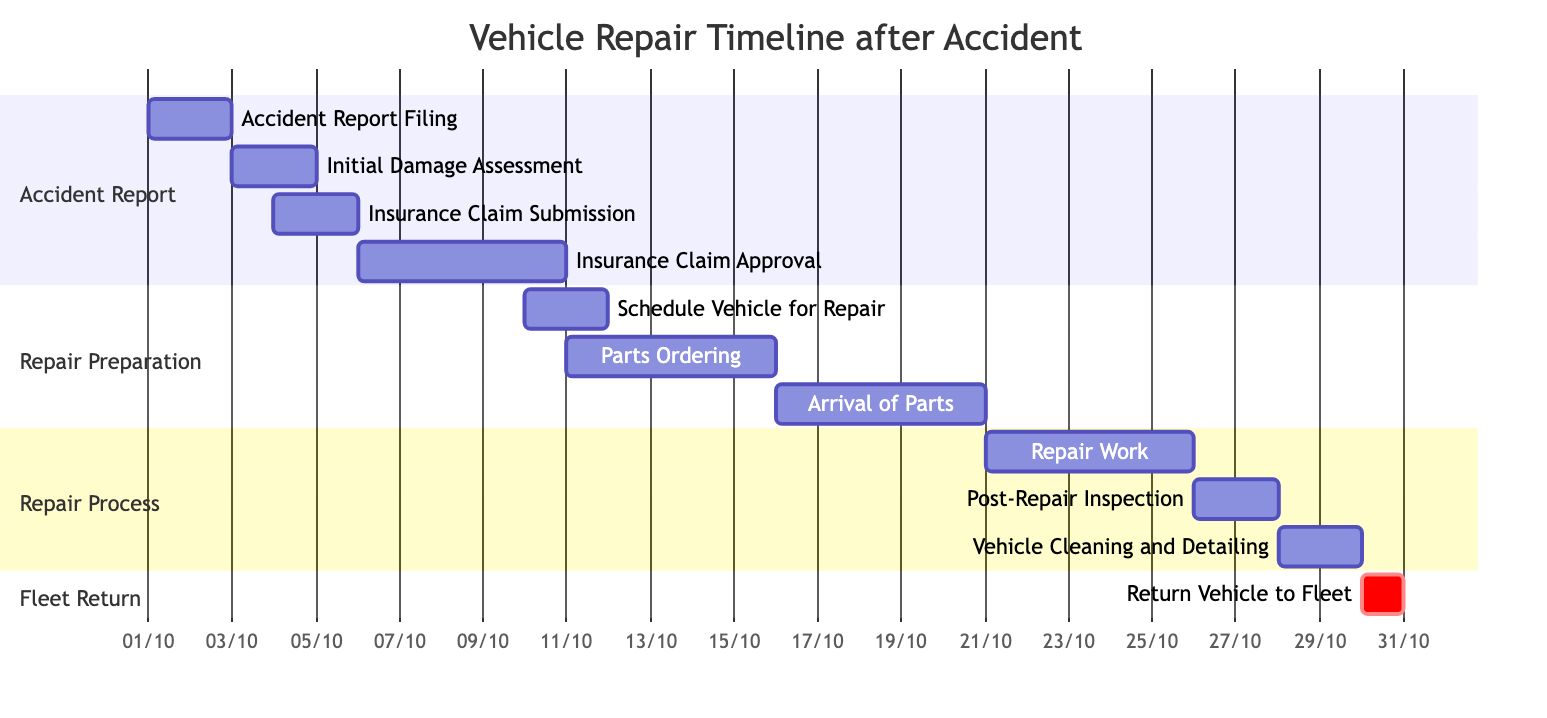What is the duration of the "Insurance Claim Approval" task? The "Insurance Claim Approval" task starts on 2023-10-06 and ends on 2023-10-10. To find the duration, we count the number of days between the start and end dates, which is 5 days.
Answer: 5 days Which task is set to commence right after "Initial Damage Assessment"? The "Insurance Claim Submission" task is dependent on the "Initial Damage Assessment", meaning it cannot start until that task is completed. The "Initial Damage Assessment" finishes on 2023-10-04, thus the next task starts immediately after.
Answer: Insurance Claim Submission How many tasks are there in the "Repair Process" section? The "Repair Process" section has three tasks: "Repair Work", "Post-Repair Inspection", and "Vehicle Cleaning and Detailing". Counting these tasks gives us a total of 3.
Answer: 3 What is the start date of the "Repair Work" task? The "Repair Work" task is listed to start on 2023-10-21. This is explicitly shown in the diagram under the "Repair Process" section.
Answer: 2023-10-21 What task immediately precedes the "Return Vehicle to Fleet"? The "Vehicle Cleaning and Detailing" task is the task that immediately precedes the "Return Vehicle to Fleet". The diagram shows that "Vehicle Cleaning and Detailing" must finish before the vehicle can be returned.
Answer: Vehicle Cleaning and Detailing Is the task "Parts Ordering" dependent on any other tasks? Yes, the "Parts Ordering" task is dependent on the "Schedule Vehicle for Repair" task. This is indicated by the dependency listed in the diagram, meaning it cannot start until scheduling is complete.
Answer: Yes What is the total number of days from the "Accident Report Filing" to the completion of the "Return Vehicle to Fleet"? The timeline starts from "Accident Report Filing" on 2023-10-01 and ends with "Return Vehicle to Fleet" on 2023-10-30. To calculate the total number of days, we consider the time from the start to the end date, which is 30 days.
Answer: 30 days Which section includes the "Post-Repair Inspection"? The "Post-Repair Inspection" task is included in the "Repair Process" section of the Gantt chart. This is where various tasks related to the repairs are grouped together.
Answer: Repair Process When does the process of "Parts Ordering" begin? The "Parts Ordering" begins on 2023-10-11. This is identified by looking at the start date indicated for that task in the diagram.
Answer: 2023-10-11 